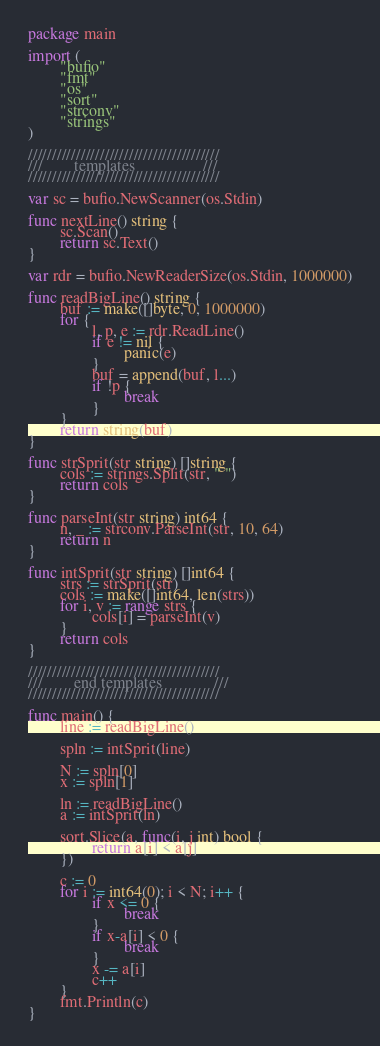Convert code to text. <code><loc_0><loc_0><loc_500><loc_500><_Go_>package main

import (
        "bufio"
        "fmt"
        "os"
        "sort"
        "strconv"
        "strings"
)

////////////////////////////////////////
///        templates                 ///
////////////////////////////////////////

var sc = bufio.NewScanner(os.Stdin)

func nextLine() string {
        sc.Scan()
        return sc.Text()
}

var rdr = bufio.NewReaderSize(os.Stdin, 1000000)

func readBigLine() string {
        buf := make([]byte, 0, 1000000)
        for {
                l, p, e := rdr.ReadLine()
                if e != nil {
                        panic(e)
                }
                buf = append(buf, l...)
                if !p {
                        break
                }
        }
        return string(buf)
}

func strSprit(str string) []string {
        cols := strings.Split(str, " ")
        return cols
}

func parseInt(str string) int64 {
        n, _ := strconv.ParseInt(str, 10, 64)
        return n
}

func intSprit(str string) []int64 {
        strs := strSprit(str)
        cols := make([]int64, len(strs))
        for i, v := range strs {
                cols[i] = parseInt(v)
        }
        return cols
}

////////////////////////////////////////
///        end templates             ///
////////////////////////////////////////

func main() {
        line := readBigLine()

        spln := intSprit(line)

        N := spln[0]
        x := spln[1]

        ln := readBigLine()
        a := intSprit(ln)

        sort.Slice(a, func(i, j int) bool {
                return a[i] < a[j]
        })

        c := 0
        for i := int64(0); i < N; i++ {
                if x <= 0 {
                        break
                }
                if x-a[i] < 0 {
                        break
                }
                x -= a[i]
                c++
        }
        fmt.Println(c)
}

</code> 